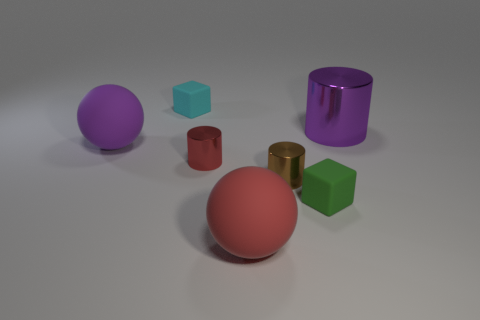Add 1 purple shiny things. How many objects exist? 8 Subtract all spheres. How many objects are left? 5 Subtract all brown shiny blocks. Subtract all big purple matte objects. How many objects are left? 6 Add 7 metallic objects. How many metallic objects are left? 10 Add 1 large brown balls. How many large brown balls exist? 1 Subtract 0 brown balls. How many objects are left? 7 